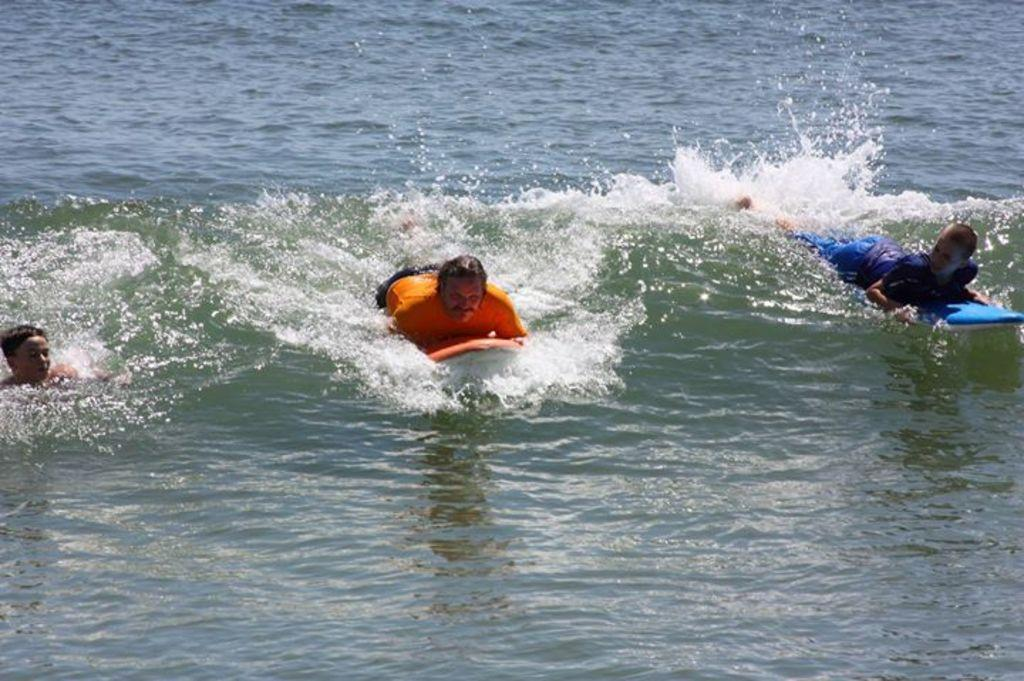Who or what is present in the image? There are people in the image. What are the people holding in their hands? The people are holding boards in the image. What can be seen at the bottom of the image? There is water visible at the bottom of the image. What type of force can be seen pushing the people in the image? There is no force pushing the people in the image; they are holding boards. Can you see any pickles in the image? There are no pickles present in the image. 